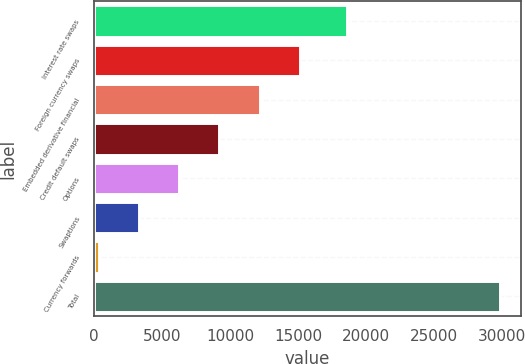<chart> <loc_0><loc_0><loc_500><loc_500><bar_chart><fcel>Interest rate swaps<fcel>Foreign currency swaps<fcel>Embedded derivative financial<fcel>Credit default swaps<fcel>Options<fcel>Swaptions<fcel>Currency forwards<fcel>Total<nl><fcel>18627.3<fcel>15116.2<fcel>12165.4<fcel>9214.51<fcel>6263.64<fcel>3312.77<fcel>361.9<fcel>29870.6<nl></chart> 